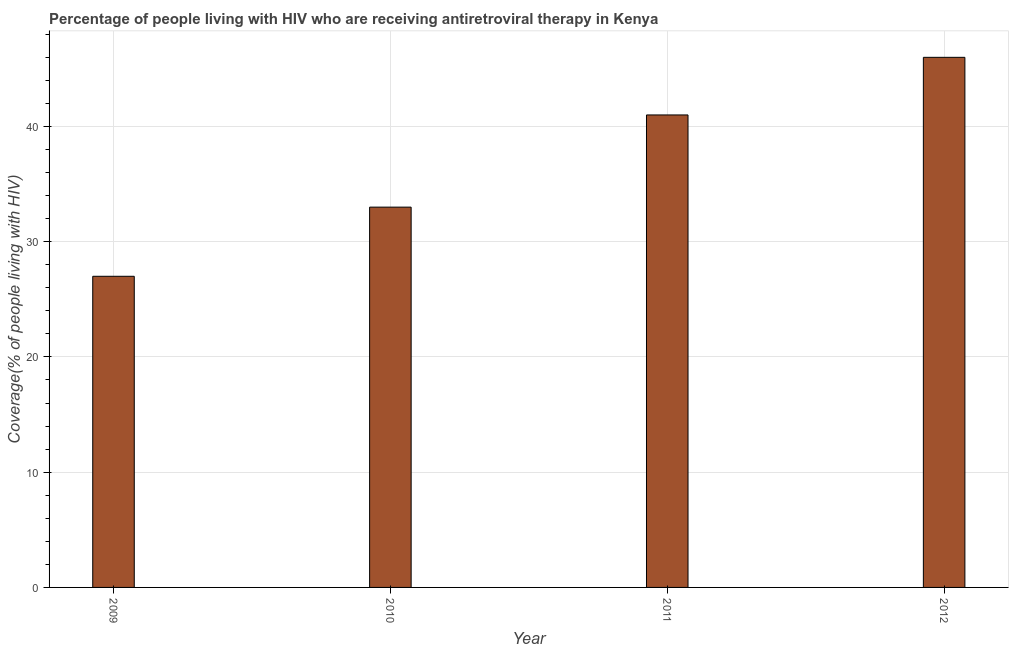Does the graph contain any zero values?
Your response must be concise. No. What is the title of the graph?
Provide a succinct answer. Percentage of people living with HIV who are receiving antiretroviral therapy in Kenya. What is the label or title of the Y-axis?
Provide a succinct answer. Coverage(% of people living with HIV). Across all years, what is the minimum antiretroviral therapy coverage?
Offer a terse response. 27. In which year was the antiretroviral therapy coverage maximum?
Provide a succinct answer. 2012. In which year was the antiretroviral therapy coverage minimum?
Give a very brief answer. 2009. What is the sum of the antiretroviral therapy coverage?
Give a very brief answer. 147. What is the difference between the antiretroviral therapy coverage in 2009 and 2011?
Offer a very short reply. -14. What is the ratio of the antiretroviral therapy coverage in 2011 to that in 2012?
Your answer should be compact. 0.89. Is the difference between the antiretroviral therapy coverage in 2010 and 2011 greater than the difference between any two years?
Provide a succinct answer. No. What is the difference between the highest and the second highest antiretroviral therapy coverage?
Your response must be concise. 5. How many years are there in the graph?
Your response must be concise. 4. What is the difference between two consecutive major ticks on the Y-axis?
Your response must be concise. 10. Are the values on the major ticks of Y-axis written in scientific E-notation?
Offer a very short reply. No. What is the Coverage(% of people living with HIV) of 2010?
Offer a very short reply. 33. What is the difference between the Coverage(% of people living with HIV) in 2010 and 2011?
Provide a short and direct response. -8. What is the difference between the Coverage(% of people living with HIV) in 2010 and 2012?
Your response must be concise. -13. What is the difference between the Coverage(% of people living with HIV) in 2011 and 2012?
Provide a succinct answer. -5. What is the ratio of the Coverage(% of people living with HIV) in 2009 to that in 2010?
Offer a very short reply. 0.82. What is the ratio of the Coverage(% of people living with HIV) in 2009 to that in 2011?
Provide a short and direct response. 0.66. What is the ratio of the Coverage(% of people living with HIV) in 2009 to that in 2012?
Keep it short and to the point. 0.59. What is the ratio of the Coverage(% of people living with HIV) in 2010 to that in 2011?
Provide a short and direct response. 0.81. What is the ratio of the Coverage(% of people living with HIV) in 2010 to that in 2012?
Offer a very short reply. 0.72. What is the ratio of the Coverage(% of people living with HIV) in 2011 to that in 2012?
Ensure brevity in your answer.  0.89. 